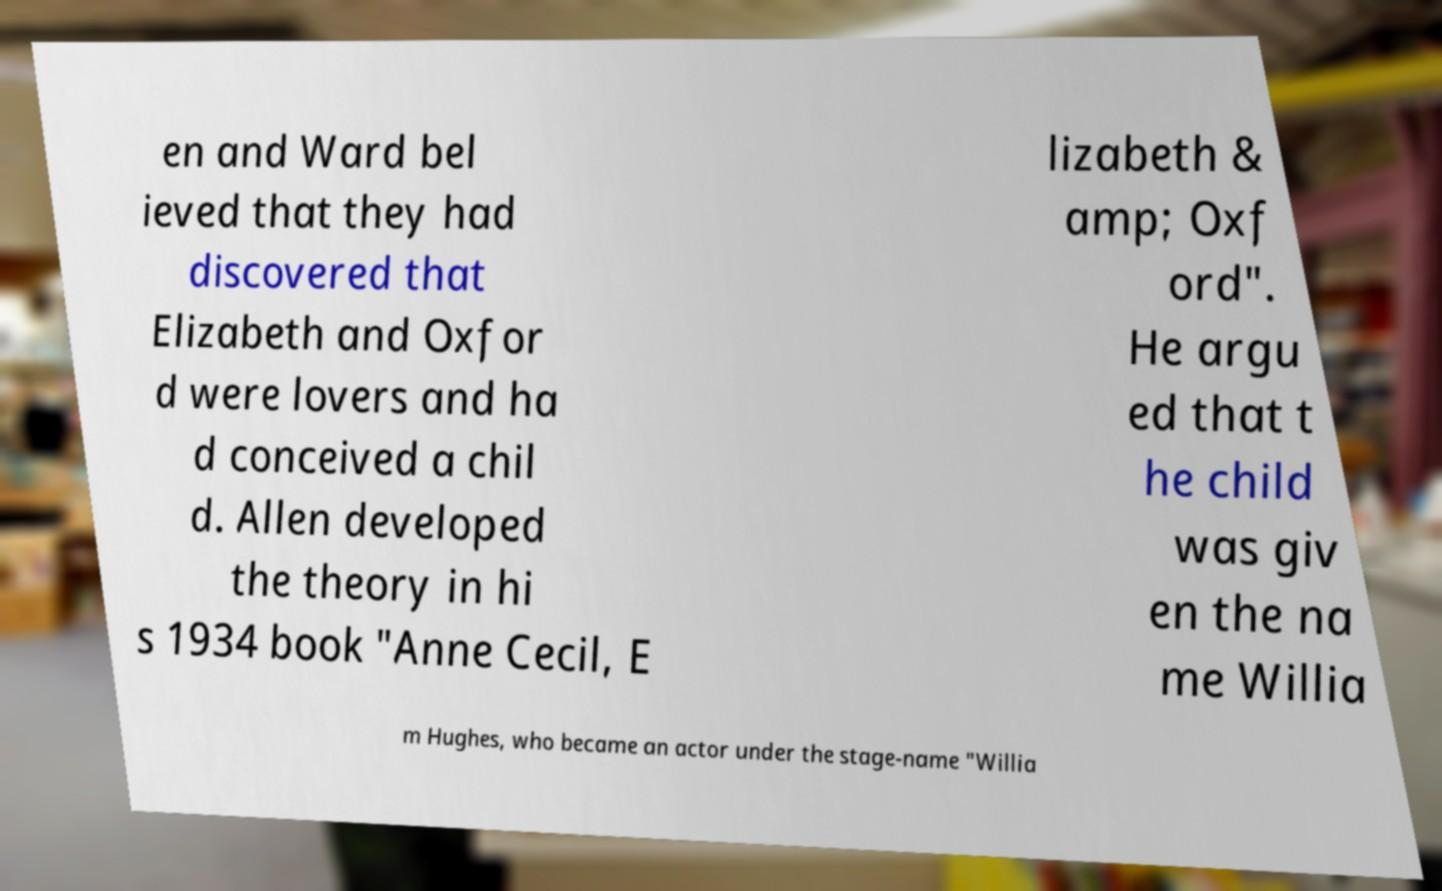What messages or text are displayed in this image? I need them in a readable, typed format. en and Ward bel ieved that they had discovered that Elizabeth and Oxfor d were lovers and ha d conceived a chil d. Allen developed the theory in hi s 1934 book "Anne Cecil, E lizabeth & amp; Oxf ord". He argu ed that t he child was giv en the na me Willia m Hughes, who became an actor under the stage-name "Willia 